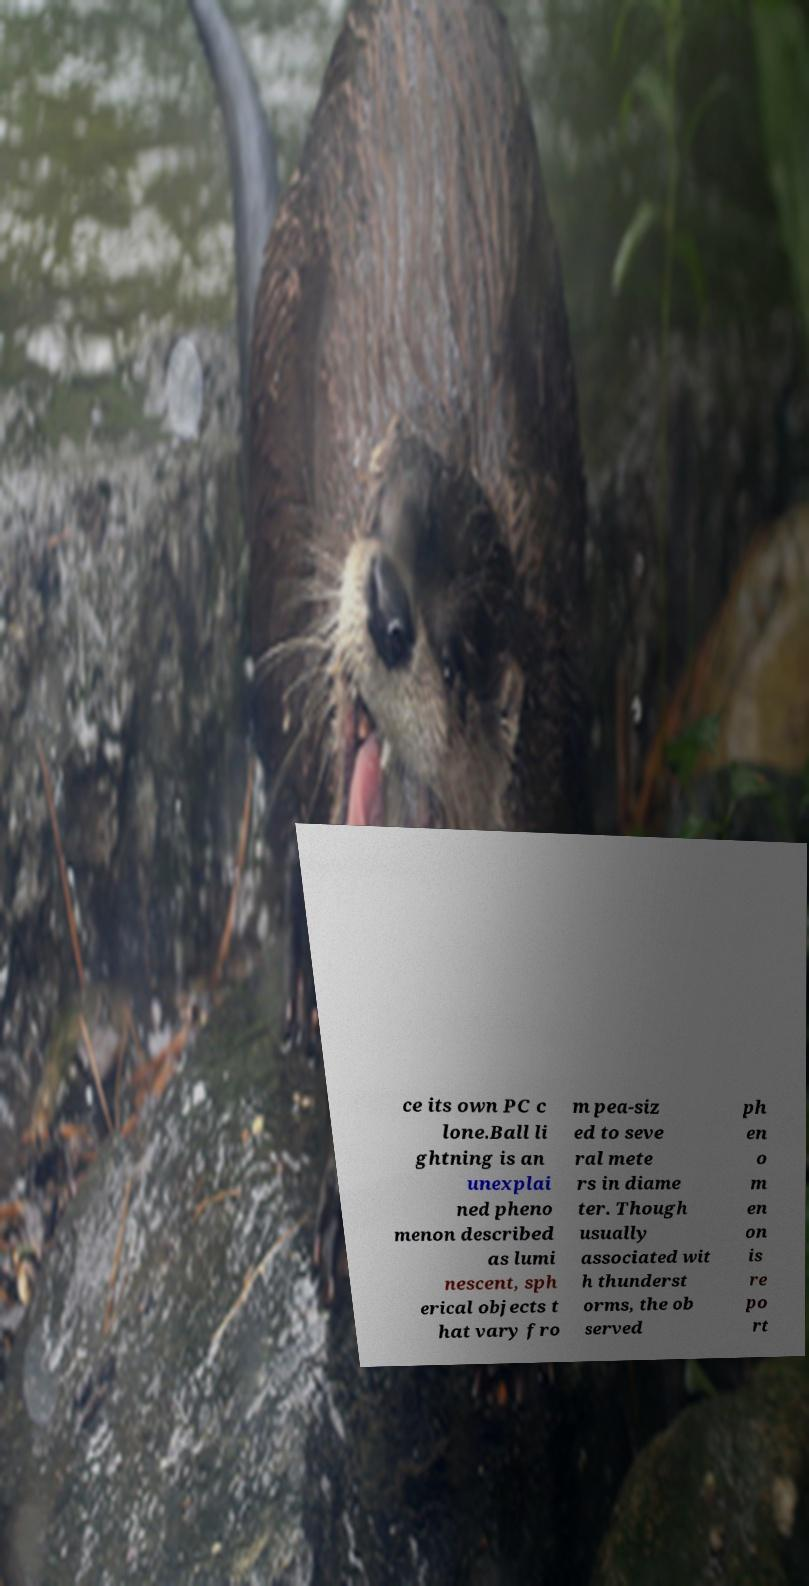Could you assist in decoding the text presented in this image and type it out clearly? ce its own PC c lone.Ball li ghtning is an unexplai ned pheno menon described as lumi nescent, sph erical objects t hat vary fro m pea-siz ed to seve ral mete rs in diame ter. Though usually associated wit h thunderst orms, the ob served ph en o m en on is re po rt 